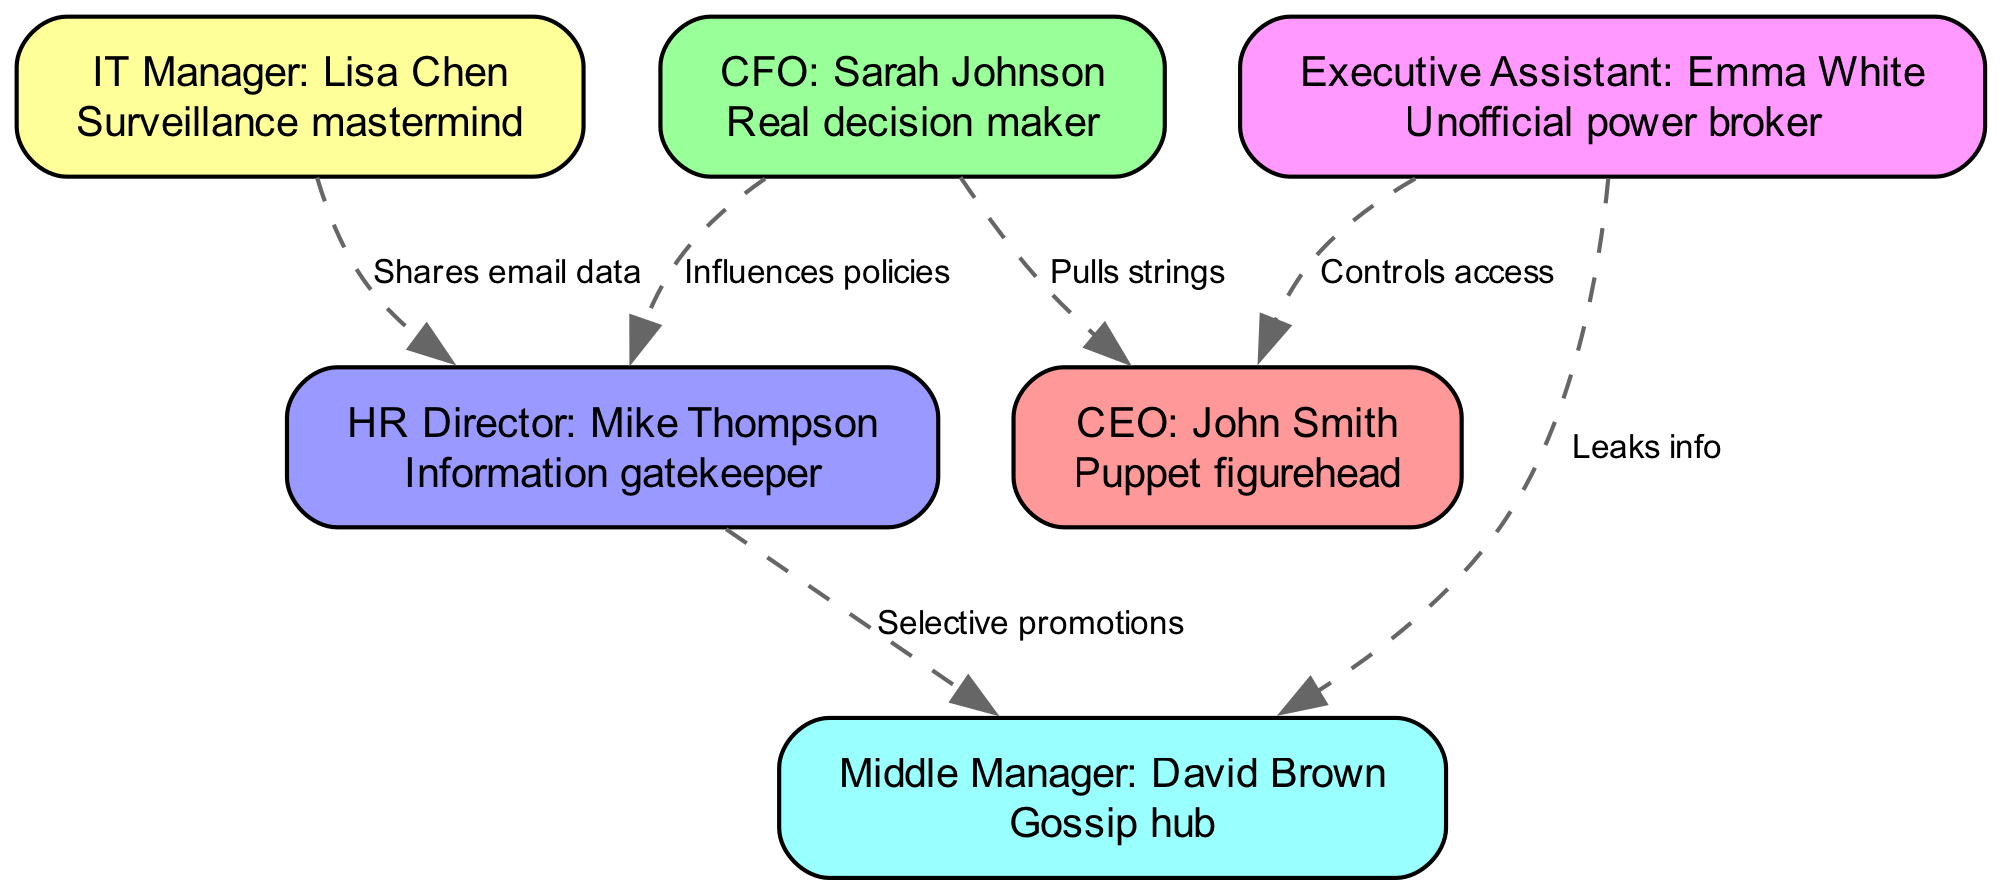What is the role of the CEO in this diagram? The diagram states that the CEO, John Smith, is described as a "Puppet figurehead." This indicates that while he holds the title of CEO, he lacks true control or influence over the company's decisions.
Answer: Puppet figurehead Who is depicted as the real decision maker? The diagram labels the CFO, Sarah Johnson, as the "Real decision maker," meaning she holds significant power and authority in making corporate decisions, overshadowing the CEO's role.
Answer: Real decision maker How many total nodes are represented in the diagram? By counting each of the unique roles listed in the nodes section, it can be determined there are six nodes: CEO, CFO, HR, IT, EA, and MidManager.
Answer: 6 What relationship exists between the CFO and the CEO? The diagram explicitly states that the CFO "Pulls strings" to the CEO. This shows that the CFO has a manipulative influence over the CEO, suggesting control and power dynamics between them.
Answer: Pulls strings How does the Executive Assistant influence communication? The Executive Assistant, Emma White, is noted to "Control access" to the CEO, indicating that she manages who can communicate with the CEO and potentially filters information.
Answer: Controls access Which role is responsible for managing promotions, according to the diagram? According to the relationships in the diagram, the HR Director, Mike Thompson, is responsible for "Selective promotions," highlighting their role in deciding who advances within the company.
Answer: Selective promotions What channel does the IT Manager use to share information? The IT Manager, Lisa Chen, is identified as sharing "email data" with the HR Director, which points to a method of information exchange that affects HR operations.
Answer: Shares email data Who is described as an unofficial power broker? The diagram notes that the Executive Assistant, Emma White, acts as an "Unofficial power broker," indicating her role in influencing decisions and relationships in the corporate hierarchy.
Answer: Unofficial power broker What is the significance of the edges being dashed in the diagram? The use of dashed edges implies a non-official or informal connection between the roles, suggesting that the influences and interactions are not part of the formal organizational structure.
Answer: Non-official connections 